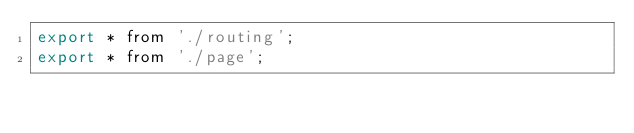<code> <loc_0><loc_0><loc_500><loc_500><_JavaScript_>export * from './routing';
export * from './page';
</code> 